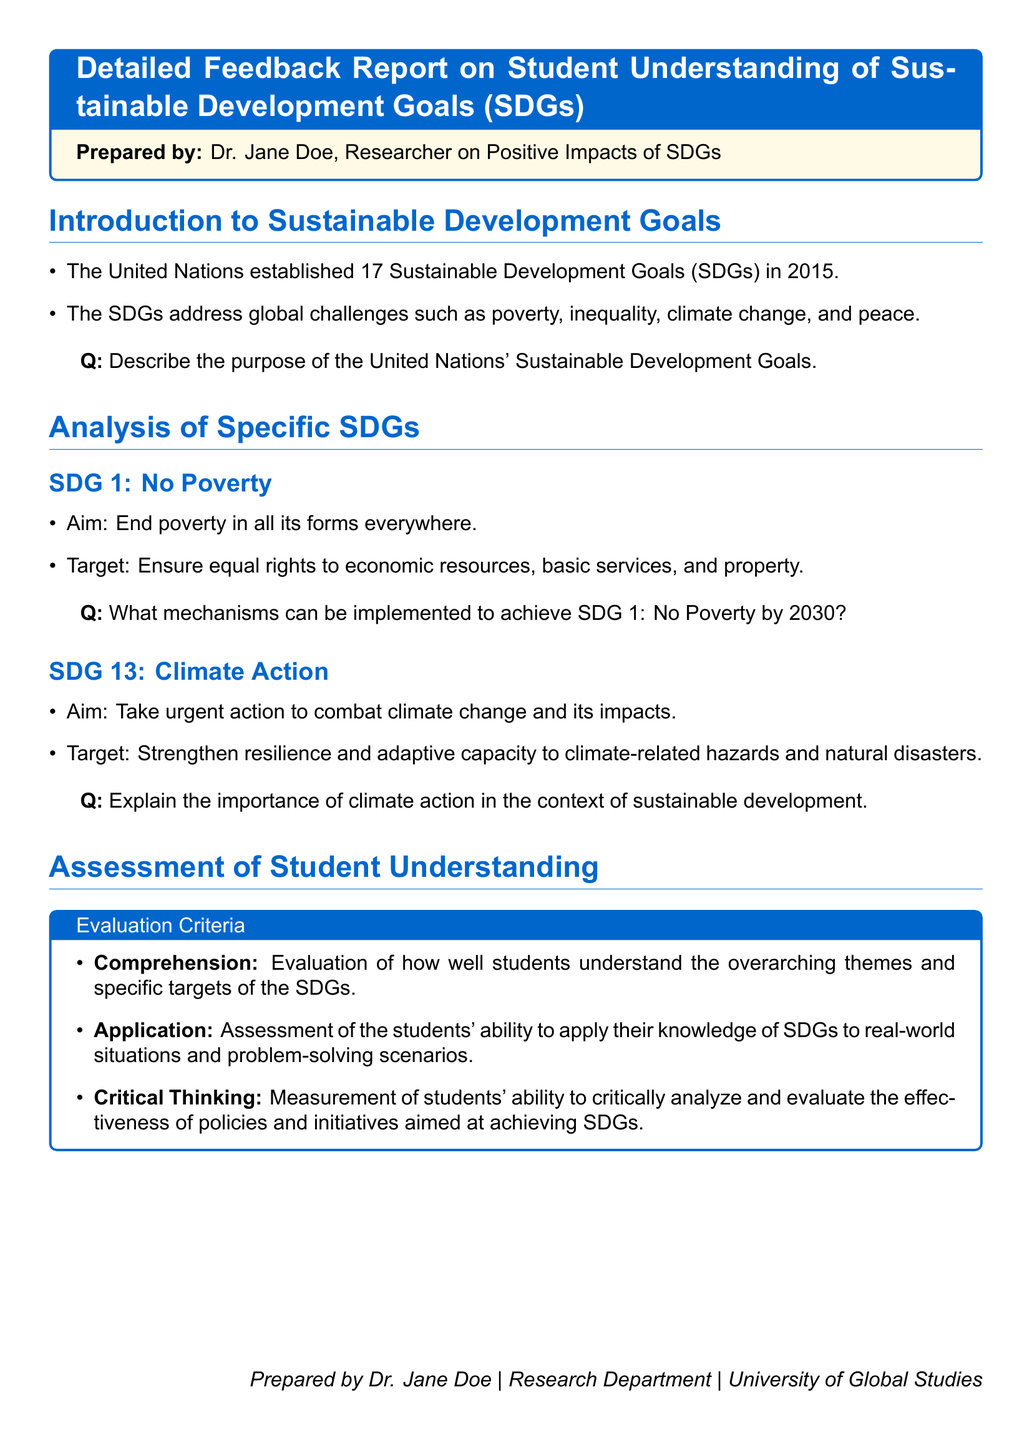What are the Sustainable Development Goals? The Sustainable Development Goals are a set of 17 goals established by the United Nations to address global challenges such as poverty, inequality, climate change, and peace.
Answer: 17 goals Who prepared the Detailed Feedback Report? The document indicates that it was prepared by Dr. Jane Doe, a researcher on positive impacts of SDGs.
Answer: Dr. Jane Doe What is the aim of SDG 1? The aim of SDG 1 is to end poverty in all its forms everywhere.
Answer: End poverty in all its forms everywhere What does SDG 13 focus on? SDG 13 focuses on taking urgent action to combat climate change and its impacts.
Answer: Climate action What is one target of SDG 1? One target of SDG 1 is to ensure equal rights to economic resources, basic services, and property.
Answer: Ensure equal rights to economic resources What three evaluation criteria are used to assess student understanding? The evaluation criteria are comprehension, application, and critical thinking.
Answer: Comprehension, application, critical thinking What is the date when the SDGs were established? The Sustainable Development Goals were established in 2015.
Answer: 2015 In which department does Dr. Jane Doe work? Dr. Jane Doe works in the Research Department at the University of Global Studies.
Answer: Research Department 